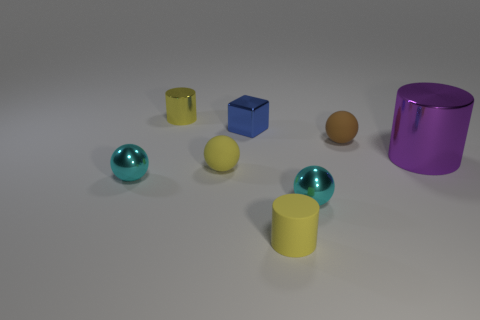What size is the yellow ball that is the same material as the brown sphere?
Your answer should be compact. Small. How many yellow objects have the same shape as the brown rubber object?
Keep it short and to the point. 1. What number of things are either cyan shiny objects that are on the right side of the yellow sphere or small metallic things that are behind the large purple cylinder?
Your answer should be compact. 3. There is a tiny shiny sphere that is on the left side of the tiny blue metallic object; what number of yellow balls are in front of it?
Provide a succinct answer. 0. There is a metallic object that is to the right of the brown rubber object; does it have the same shape as the yellow rubber object that is to the right of the blue thing?
Offer a terse response. Yes. What shape is the shiny thing that is the same color as the rubber cylinder?
Provide a succinct answer. Cylinder. Are there any small cyan objects that have the same material as the big purple cylinder?
Provide a short and direct response. Yes. How many matte things are either brown things or small blue cubes?
Offer a very short reply. 1. What is the shape of the blue shiny thing behind the matte object behind the large purple cylinder?
Your response must be concise. Cube. Are there fewer brown rubber spheres to the left of the yellow matte sphere than large red rubber cylinders?
Keep it short and to the point. No. 